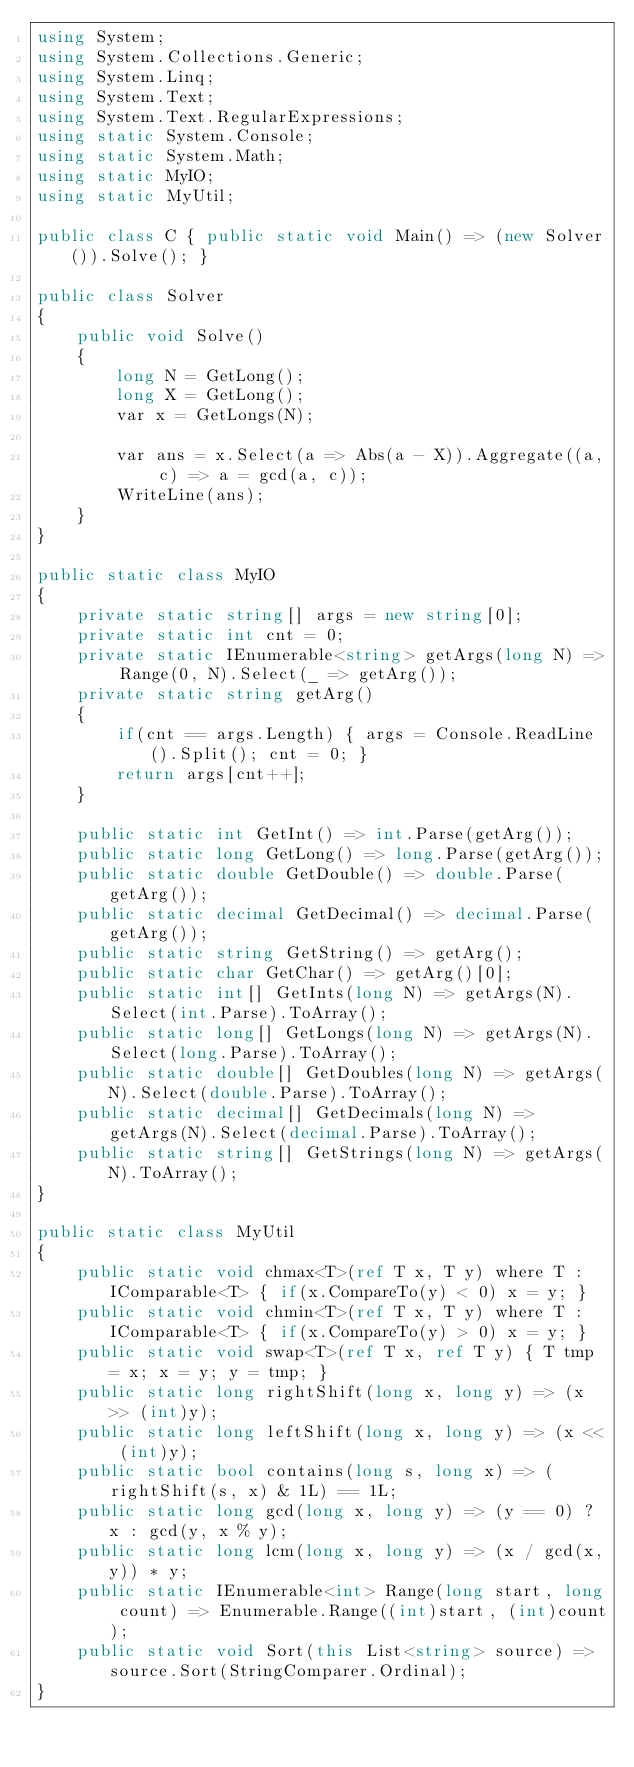<code> <loc_0><loc_0><loc_500><loc_500><_C#_>using System;
using System.Collections.Generic;
using System.Linq;
using System.Text;
using System.Text.RegularExpressions;
using static System.Console;
using static System.Math;
using static MyIO;
using static MyUtil;

public class C { public static void Main() => (new Solver()).Solve(); }

public class Solver
{
	public void Solve()
	{
		long N = GetLong();
		long X = GetLong();
		var x = GetLongs(N);

		var ans = x.Select(a => Abs(a - X)).Aggregate((a, c) => a = gcd(a, c));
		WriteLine(ans);
	}
}

public static class MyIO
{
	private static string[] args = new string[0];
	private static int cnt = 0;
	private static IEnumerable<string> getArgs(long N) => Range(0, N).Select(_ => getArg());
	private static string getArg()
	{
		if(cnt == args.Length) { args = Console.ReadLine().Split(); cnt = 0; }
		return args[cnt++];
	}

	public static int GetInt() => int.Parse(getArg());
	public static long GetLong() => long.Parse(getArg());
	public static double GetDouble() => double.Parse(getArg());
	public static decimal GetDecimal() => decimal.Parse(getArg());
	public static string GetString() => getArg();
	public static char GetChar() => getArg()[0];
	public static int[] GetInts(long N) => getArgs(N).Select(int.Parse).ToArray();
	public static long[] GetLongs(long N) => getArgs(N).Select(long.Parse).ToArray();
	public static double[] GetDoubles(long N) => getArgs(N).Select(double.Parse).ToArray();
	public static decimal[] GetDecimals(long N) => getArgs(N).Select(decimal.Parse).ToArray();
	public static string[] GetStrings(long N) => getArgs(N).ToArray();
}

public static class MyUtil
{
	public static void chmax<T>(ref T x, T y) where T : IComparable<T> { if(x.CompareTo(y) < 0) x = y; }
	public static void chmin<T>(ref T x, T y) where T : IComparable<T> { if(x.CompareTo(y) > 0)	x = y; }
	public static void swap<T>(ref T x, ref T y) { T tmp = x; x = y; y = tmp; }
	public static long rightShift(long x, long y) => (x >> (int)y);
	public static long leftShift(long x, long y) => (x << (int)y);
	public static bool contains(long s, long x) => (rightShift(s, x) & 1L) == 1L;
	public static long gcd(long x, long y) => (y == 0) ? x : gcd(y, x % y);
	public static long lcm(long x, long y) => (x / gcd(x,y)) * y;	
	public static IEnumerable<int> Range(long start, long count) => Enumerable.Range((int)start, (int)count);
	public static void Sort(this List<string> source) => source.Sort(StringComparer.Ordinal);
}
</code> 